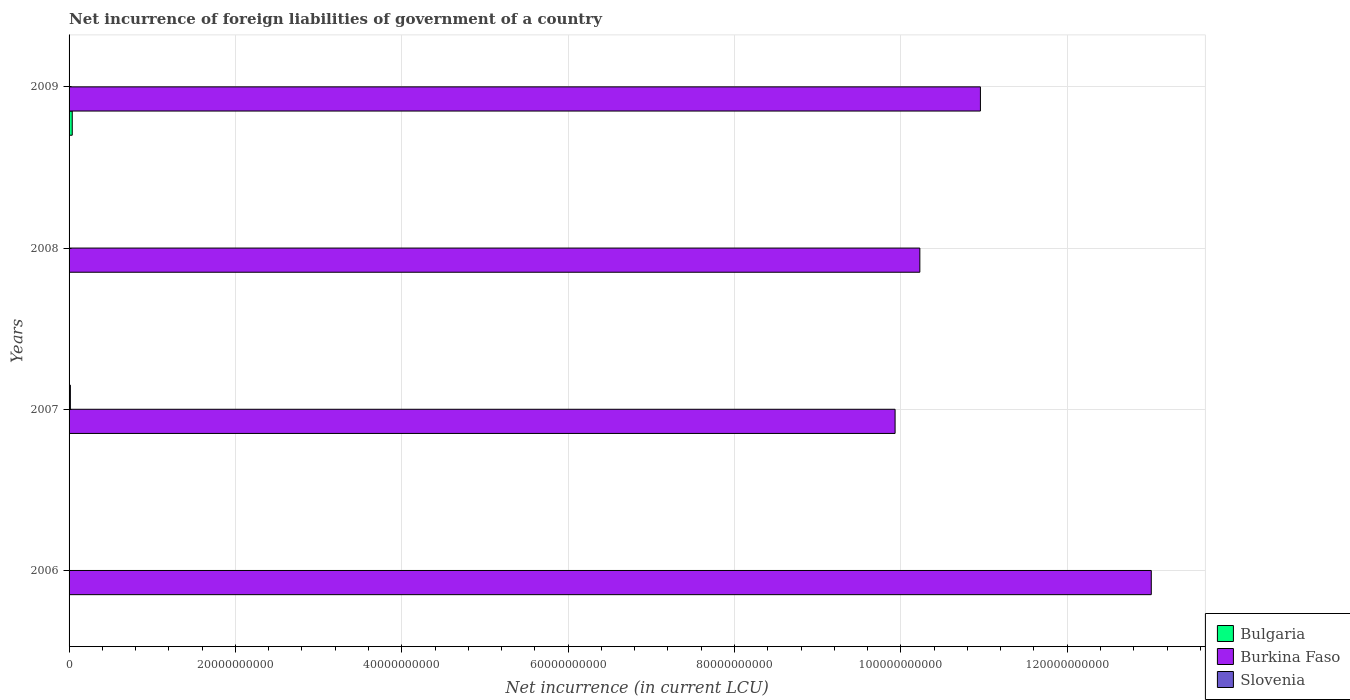How many different coloured bars are there?
Give a very brief answer. 3. Are the number of bars on each tick of the Y-axis equal?
Ensure brevity in your answer.  No. What is the label of the 3rd group of bars from the top?
Your answer should be compact. 2007. Across all years, what is the maximum net incurrence of foreign liabilities in Bulgaria?
Your response must be concise. 3.83e+08. In which year was the net incurrence of foreign liabilities in Burkina Faso maximum?
Ensure brevity in your answer.  2006. What is the total net incurrence of foreign liabilities in Burkina Faso in the graph?
Provide a short and direct response. 4.41e+11. What is the difference between the net incurrence of foreign liabilities in Burkina Faso in 2006 and that in 2009?
Provide a succinct answer. 2.05e+1. What is the difference between the net incurrence of foreign liabilities in Bulgaria in 2009 and the net incurrence of foreign liabilities in Slovenia in 2008?
Offer a terse response. 3.83e+08. What is the average net incurrence of foreign liabilities in Slovenia per year?
Your answer should be very brief. 3.91e+07. In the year 2007, what is the difference between the net incurrence of foreign liabilities in Slovenia and net incurrence of foreign liabilities in Burkina Faso?
Offer a terse response. -9.91e+1. In how many years, is the net incurrence of foreign liabilities in Slovenia greater than 56000000000 LCU?
Your answer should be very brief. 0. Is the net incurrence of foreign liabilities in Burkina Faso in 2008 less than that in 2009?
Your answer should be compact. Yes. What is the difference between the highest and the second highest net incurrence of foreign liabilities in Burkina Faso?
Offer a terse response. 2.05e+1. What is the difference between the highest and the lowest net incurrence of foreign liabilities in Slovenia?
Provide a short and direct response. 1.57e+08. Is it the case that in every year, the sum of the net incurrence of foreign liabilities in Slovenia and net incurrence of foreign liabilities in Burkina Faso is greater than the net incurrence of foreign liabilities in Bulgaria?
Your answer should be compact. Yes. Are all the bars in the graph horizontal?
Give a very brief answer. Yes. What is the difference between two consecutive major ticks on the X-axis?
Keep it short and to the point. 2.00e+1. Are the values on the major ticks of X-axis written in scientific E-notation?
Make the answer very short. No. Does the graph contain any zero values?
Provide a succinct answer. Yes. Does the graph contain grids?
Offer a very short reply. Yes. How are the legend labels stacked?
Offer a terse response. Vertical. What is the title of the graph?
Your response must be concise. Net incurrence of foreign liabilities of government of a country. Does "Seychelles" appear as one of the legend labels in the graph?
Offer a terse response. No. What is the label or title of the X-axis?
Give a very brief answer. Net incurrence (in current LCU). What is the label or title of the Y-axis?
Give a very brief answer. Years. What is the Net incurrence (in current LCU) in Burkina Faso in 2006?
Your answer should be compact. 1.30e+11. What is the Net incurrence (in current LCU) in Slovenia in 2006?
Provide a succinct answer. 0. What is the Net incurrence (in current LCU) in Burkina Faso in 2007?
Your response must be concise. 9.93e+1. What is the Net incurrence (in current LCU) in Slovenia in 2007?
Your answer should be compact. 1.57e+08. What is the Net incurrence (in current LCU) in Bulgaria in 2008?
Provide a short and direct response. 0. What is the Net incurrence (in current LCU) of Burkina Faso in 2008?
Ensure brevity in your answer.  1.02e+11. What is the Net incurrence (in current LCU) in Slovenia in 2008?
Make the answer very short. 0. What is the Net incurrence (in current LCU) in Bulgaria in 2009?
Keep it short and to the point. 3.83e+08. What is the Net incurrence (in current LCU) of Burkina Faso in 2009?
Keep it short and to the point. 1.10e+11. Across all years, what is the maximum Net incurrence (in current LCU) in Bulgaria?
Your answer should be very brief. 3.83e+08. Across all years, what is the maximum Net incurrence (in current LCU) of Burkina Faso?
Ensure brevity in your answer.  1.30e+11. Across all years, what is the maximum Net incurrence (in current LCU) of Slovenia?
Your response must be concise. 1.57e+08. Across all years, what is the minimum Net incurrence (in current LCU) of Burkina Faso?
Provide a short and direct response. 9.93e+1. Across all years, what is the minimum Net incurrence (in current LCU) in Slovenia?
Your answer should be very brief. 0. What is the total Net incurrence (in current LCU) in Bulgaria in the graph?
Offer a very short reply. 3.83e+08. What is the total Net incurrence (in current LCU) in Burkina Faso in the graph?
Give a very brief answer. 4.41e+11. What is the total Net incurrence (in current LCU) in Slovenia in the graph?
Ensure brevity in your answer.  1.57e+08. What is the difference between the Net incurrence (in current LCU) in Burkina Faso in 2006 and that in 2007?
Provide a succinct answer. 3.08e+1. What is the difference between the Net incurrence (in current LCU) of Burkina Faso in 2006 and that in 2008?
Keep it short and to the point. 2.78e+1. What is the difference between the Net incurrence (in current LCU) of Burkina Faso in 2006 and that in 2009?
Keep it short and to the point. 2.05e+1. What is the difference between the Net incurrence (in current LCU) in Burkina Faso in 2007 and that in 2008?
Your answer should be compact. -2.98e+09. What is the difference between the Net incurrence (in current LCU) in Burkina Faso in 2007 and that in 2009?
Give a very brief answer. -1.03e+1. What is the difference between the Net incurrence (in current LCU) in Burkina Faso in 2008 and that in 2009?
Offer a terse response. -7.28e+09. What is the difference between the Net incurrence (in current LCU) in Burkina Faso in 2006 and the Net incurrence (in current LCU) in Slovenia in 2007?
Your answer should be compact. 1.30e+11. What is the average Net incurrence (in current LCU) of Bulgaria per year?
Your answer should be compact. 9.58e+07. What is the average Net incurrence (in current LCU) of Burkina Faso per year?
Offer a terse response. 1.10e+11. What is the average Net incurrence (in current LCU) of Slovenia per year?
Your response must be concise. 3.91e+07. In the year 2007, what is the difference between the Net incurrence (in current LCU) in Burkina Faso and Net incurrence (in current LCU) in Slovenia?
Keep it short and to the point. 9.91e+1. In the year 2009, what is the difference between the Net incurrence (in current LCU) in Bulgaria and Net incurrence (in current LCU) in Burkina Faso?
Make the answer very short. -1.09e+11. What is the ratio of the Net incurrence (in current LCU) in Burkina Faso in 2006 to that in 2007?
Keep it short and to the point. 1.31. What is the ratio of the Net incurrence (in current LCU) in Burkina Faso in 2006 to that in 2008?
Provide a succinct answer. 1.27. What is the ratio of the Net incurrence (in current LCU) in Burkina Faso in 2006 to that in 2009?
Ensure brevity in your answer.  1.19. What is the ratio of the Net incurrence (in current LCU) of Burkina Faso in 2007 to that in 2008?
Your answer should be very brief. 0.97. What is the ratio of the Net incurrence (in current LCU) of Burkina Faso in 2007 to that in 2009?
Offer a terse response. 0.91. What is the ratio of the Net incurrence (in current LCU) of Burkina Faso in 2008 to that in 2009?
Ensure brevity in your answer.  0.93. What is the difference between the highest and the second highest Net incurrence (in current LCU) of Burkina Faso?
Your answer should be compact. 2.05e+1. What is the difference between the highest and the lowest Net incurrence (in current LCU) of Bulgaria?
Keep it short and to the point. 3.83e+08. What is the difference between the highest and the lowest Net incurrence (in current LCU) in Burkina Faso?
Give a very brief answer. 3.08e+1. What is the difference between the highest and the lowest Net incurrence (in current LCU) in Slovenia?
Ensure brevity in your answer.  1.57e+08. 